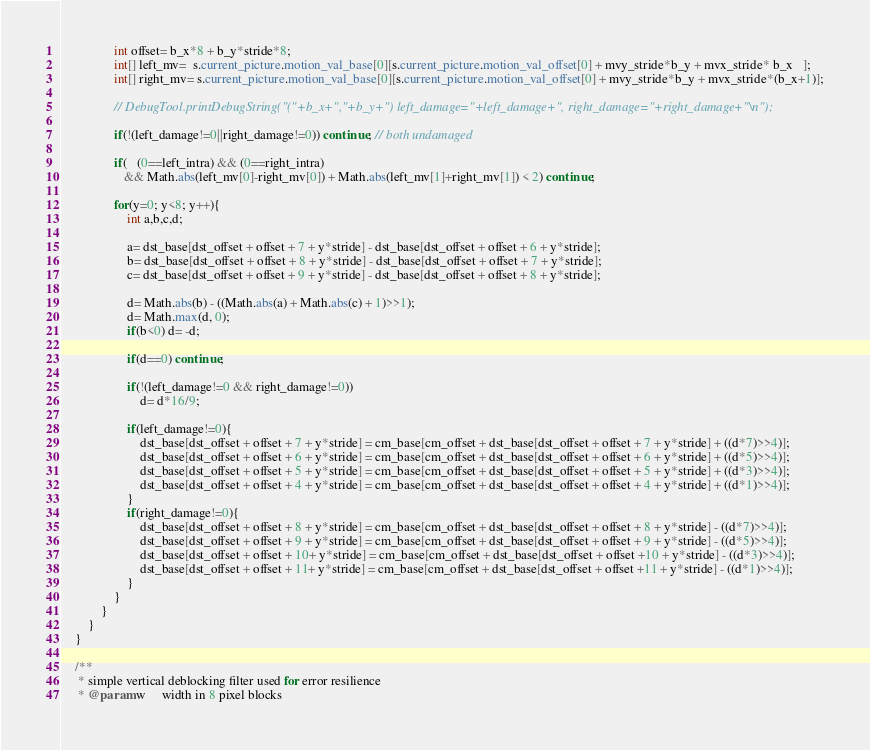<code> <loc_0><loc_0><loc_500><loc_500><_Java_>	            int offset= b_x*8 + b_y*stride*8;
	            int[] left_mv=  s.current_picture.motion_val_base[0][s.current_picture.motion_val_offset[0] + mvy_stride*b_y + mvx_stride* b_x   ];
	            int[] right_mv= s.current_picture.motion_val_base[0][s.current_picture.motion_val_offset[0] + mvy_stride*b_y + mvx_stride*(b_x+1)];

	            // DebugTool.printDebugString("("+b_x+","+b_y+") left_damage="+left_damage+", right_damage="+right_damage+"\n");
	            
	            if(!(left_damage!=0||right_damage!=0)) continue; // both undamaged

	            if(   (0==left_intra) && (0==right_intra)
	               && Math.abs(left_mv[0]-right_mv[0]) + Math.abs(left_mv[1]+right_mv[1]) < 2) continue;

	            for(y=0; y<8; y++){
	                int a,b,c,d;

	                a= dst_base[dst_offset + offset + 7 + y*stride] - dst_base[dst_offset + offset + 6 + y*stride];
	                b= dst_base[dst_offset + offset + 8 + y*stride] - dst_base[dst_offset + offset + 7 + y*stride];
	                c= dst_base[dst_offset + offset + 9 + y*stride] - dst_base[dst_offset + offset + 8 + y*stride];

	                d= Math.abs(b) - ((Math.abs(a) + Math.abs(c) + 1)>>1);
	                d= Math.max(d, 0);
	                if(b<0) d= -d;

	                if(d==0) continue;

	                if(!(left_damage!=0 && right_damage!=0))
	                    d= d*16/9;

	                if(left_damage!=0){
	                    dst_base[dst_offset + offset + 7 + y*stride] = cm_base[cm_offset + dst_base[dst_offset + offset + 7 + y*stride] + ((d*7)>>4)];
	                    dst_base[dst_offset + offset + 6 + y*stride] = cm_base[cm_offset + dst_base[dst_offset + offset + 6 + y*stride] + ((d*5)>>4)];
	                    dst_base[dst_offset + offset + 5 + y*stride] = cm_base[cm_offset + dst_base[dst_offset + offset + 5 + y*stride] + ((d*3)>>4)];
	                    dst_base[dst_offset + offset + 4 + y*stride] = cm_base[cm_offset + dst_base[dst_offset + offset + 4 + y*stride] + ((d*1)>>4)];
	                }
	                if(right_damage!=0){
	                    dst_base[dst_offset + offset + 8 + y*stride] = cm_base[cm_offset + dst_base[dst_offset + offset + 8 + y*stride] - ((d*7)>>4)];
	                    dst_base[dst_offset + offset + 9 + y*stride] = cm_base[cm_offset + dst_base[dst_offset + offset + 9 + y*stride] - ((d*5)>>4)];
	                    dst_base[dst_offset + offset + 10+ y*stride] = cm_base[cm_offset + dst_base[dst_offset + offset +10 + y*stride] - ((d*3)>>4)];
	                    dst_base[dst_offset + offset + 11+ y*stride] = cm_base[cm_offset + dst_base[dst_offset + offset +11 + y*stride] - ((d*1)>>4)];
	                }
	            }
	        }
	    }
	}

	/**
	 * simple vertical deblocking filter used for error resilience
	 * @param w     width in 8 pixel blocks</code> 